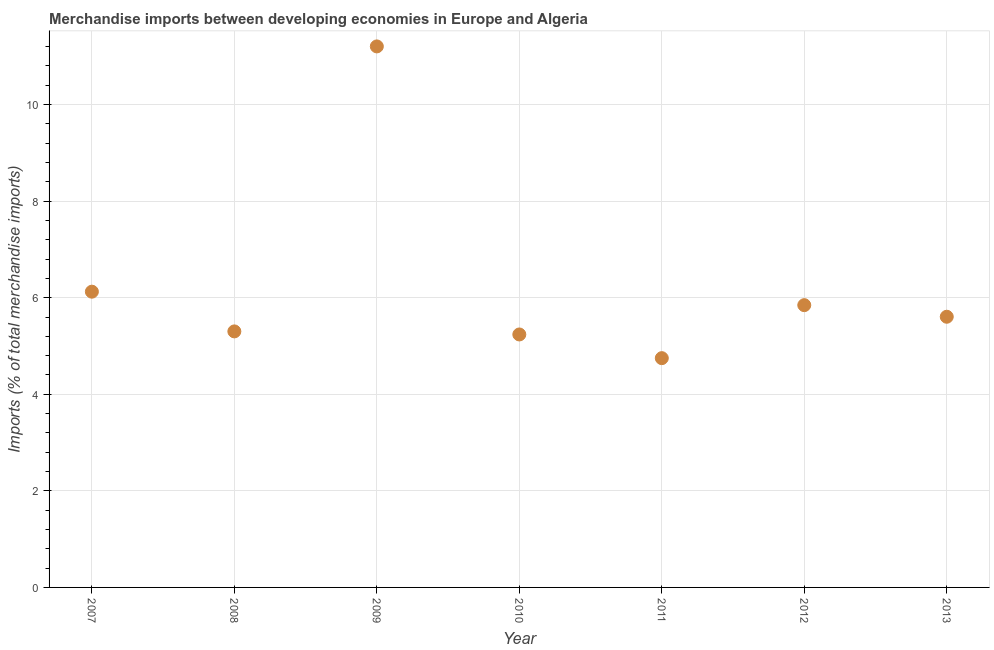What is the merchandise imports in 2011?
Provide a succinct answer. 4.75. Across all years, what is the maximum merchandise imports?
Provide a succinct answer. 11.2. Across all years, what is the minimum merchandise imports?
Ensure brevity in your answer.  4.75. What is the sum of the merchandise imports?
Your response must be concise. 44.07. What is the difference between the merchandise imports in 2008 and 2009?
Your answer should be very brief. -5.9. What is the average merchandise imports per year?
Your answer should be compact. 6.3. What is the median merchandise imports?
Provide a short and direct response. 5.61. In how many years, is the merchandise imports greater than 3.2 %?
Provide a succinct answer. 7. Do a majority of the years between 2013 and 2008 (inclusive) have merchandise imports greater than 2.8 %?
Provide a short and direct response. Yes. What is the ratio of the merchandise imports in 2007 to that in 2012?
Offer a terse response. 1.05. Is the difference between the merchandise imports in 2012 and 2013 greater than the difference between any two years?
Give a very brief answer. No. What is the difference between the highest and the second highest merchandise imports?
Keep it short and to the point. 5.08. What is the difference between the highest and the lowest merchandise imports?
Your answer should be compact. 6.46. In how many years, is the merchandise imports greater than the average merchandise imports taken over all years?
Keep it short and to the point. 1. Does the merchandise imports monotonically increase over the years?
Ensure brevity in your answer.  No. What is the difference between two consecutive major ticks on the Y-axis?
Offer a terse response. 2. Does the graph contain grids?
Ensure brevity in your answer.  Yes. What is the title of the graph?
Keep it short and to the point. Merchandise imports between developing economies in Europe and Algeria. What is the label or title of the X-axis?
Your response must be concise. Year. What is the label or title of the Y-axis?
Give a very brief answer. Imports (% of total merchandise imports). What is the Imports (% of total merchandise imports) in 2007?
Keep it short and to the point. 6.12. What is the Imports (% of total merchandise imports) in 2008?
Give a very brief answer. 5.3. What is the Imports (% of total merchandise imports) in 2009?
Provide a succinct answer. 11.2. What is the Imports (% of total merchandise imports) in 2010?
Your response must be concise. 5.24. What is the Imports (% of total merchandise imports) in 2011?
Make the answer very short. 4.75. What is the Imports (% of total merchandise imports) in 2012?
Your response must be concise. 5.85. What is the Imports (% of total merchandise imports) in 2013?
Ensure brevity in your answer.  5.61. What is the difference between the Imports (% of total merchandise imports) in 2007 and 2008?
Give a very brief answer. 0.82. What is the difference between the Imports (% of total merchandise imports) in 2007 and 2009?
Ensure brevity in your answer.  -5.08. What is the difference between the Imports (% of total merchandise imports) in 2007 and 2010?
Offer a terse response. 0.89. What is the difference between the Imports (% of total merchandise imports) in 2007 and 2011?
Provide a short and direct response. 1.38. What is the difference between the Imports (% of total merchandise imports) in 2007 and 2012?
Provide a short and direct response. 0.28. What is the difference between the Imports (% of total merchandise imports) in 2007 and 2013?
Offer a very short reply. 0.52. What is the difference between the Imports (% of total merchandise imports) in 2008 and 2009?
Your response must be concise. -5.9. What is the difference between the Imports (% of total merchandise imports) in 2008 and 2010?
Provide a short and direct response. 0.06. What is the difference between the Imports (% of total merchandise imports) in 2008 and 2011?
Provide a short and direct response. 0.55. What is the difference between the Imports (% of total merchandise imports) in 2008 and 2012?
Give a very brief answer. -0.54. What is the difference between the Imports (% of total merchandise imports) in 2008 and 2013?
Your answer should be very brief. -0.3. What is the difference between the Imports (% of total merchandise imports) in 2009 and 2010?
Make the answer very short. 5.97. What is the difference between the Imports (% of total merchandise imports) in 2009 and 2011?
Provide a succinct answer. 6.46. What is the difference between the Imports (% of total merchandise imports) in 2009 and 2012?
Keep it short and to the point. 5.36. What is the difference between the Imports (% of total merchandise imports) in 2009 and 2013?
Your answer should be compact. 5.6. What is the difference between the Imports (% of total merchandise imports) in 2010 and 2011?
Give a very brief answer. 0.49. What is the difference between the Imports (% of total merchandise imports) in 2010 and 2012?
Your answer should be very brief. -0.61. What is the difference between the Imports (% of total merchandise imports) in 2010 and 2013?
Offer a very short reply. -0.37. What is the difference between the Imports (% of total merchandise imports) in 2011 and 2012?
Ensure brevity in your answer.  -1.1. What is the difference between the Imports (% of total merchandise imports) in 2011 and 2013?
Your response must be concise. -0.86. What is the difference between the Imports (% of total merchandise imports) in 2012 and 2013?
Offer a terse response. 0.24. What is the ratio of the Imports (% of total merchandise imports) in 2007 to that in 2008?
Keep it short and to the point. 1.16. What is the ratio of the Imports (% of total merchandise imports) in 2007 to that in 2009?
Give a very brief answer. 0.55. What is the ratio of the Imports (% of total merchandise imports) in 2007 to that in 2010?
Provide a short and direct response. 1.17. What is the ratio of the Imports (% of total merchandise imports) in 2007 to that in 2011?
Provide a succinct answer. 1.29. What is the ratio of the Imports (% of total merchandise imports) in 2007 to that in 2012?
Offer a very short reply. 1.05. What is the ratio of the Imports (% of total merchandise imports) in 2007 to that in 2013?
Ensure brevity in your answer.  1.09. What is the ratio of the Imports (% of total merchandise imports) in 2008 to that in 2009?
Offer a very short reply. 0.47. What is the ratio of the Imports (% of total merchandise imports) in 2008 to that in 2010?
Keep it short and to the point. 1.01. What is the ratio of the Imports (% of total merchandise imports) in 2008 to that in 2011?
Offer a terse response. 1.12. What is the ratio of the Imports (% of total merchandise imports) in 2008 to that in 2012?
Offer a terse response. 0.91. What is the ratio of the Imports (% of total merchandise imports) in 2008 to that in 2013?
Offer a terse response. 0.95. What is the ratio of the Imports (% of total merchandise imports) in 2009 to that in 2010?
Offer a terse response. 2.14. What is the ratio of the Imports (% of total merchandise imports) in 2009 to that in 2011?
Offer a very short reply. 2.36. What is the ratio of the Imports (% of total merchandise imports) in 2009 to that in 2012?
Offer a very short reply. 1.92. What is the ratio of the Imports (% of total merchandise imports) in 2009 to that in 2013?
Your answer should be very brief. 2. What is the ratio of the Imports (% of total merchandise imports) in 2010 to that in 2011?
Your answer should be very brief. 1.1. What is the ratio of the Imports (% of total merchandise imports) in 2010 to that in 2012?
Give a very brief answer. 0.9. What is the ratio of the Imports (% of total merchandise imports) in 2010 to that in 2013?
Provide a succinct answer. 0.94. What is the ratio of the Imports (% of total merchandise imports) in 2011 to that in 2012?
Offer a very short reply. 0.81. What is the ratio of the Imports (% of total merchandise imports) in 2011 to that in 2013?
Make the answer very short. 0.85. What is the ratio of the Imports (% of total merchandise imports) in 2012 to that in 2013?
Give a very brief answer. 1.04. 